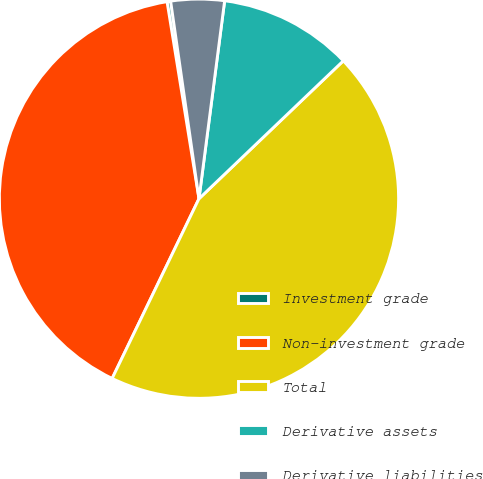<chart> <loc_0><loc_0><loc_500><loc_500><pie_chart><fcel>Investment grade<fcel>Non-investment grade<fcel>Total<fcel>Derivative assets<fcel>Derivative liabilities<nl><fcel>0.29%<fcel>40.28%<fcel>44.3%<fcel>10.81%<fcel>4.32%<nl></chart> 